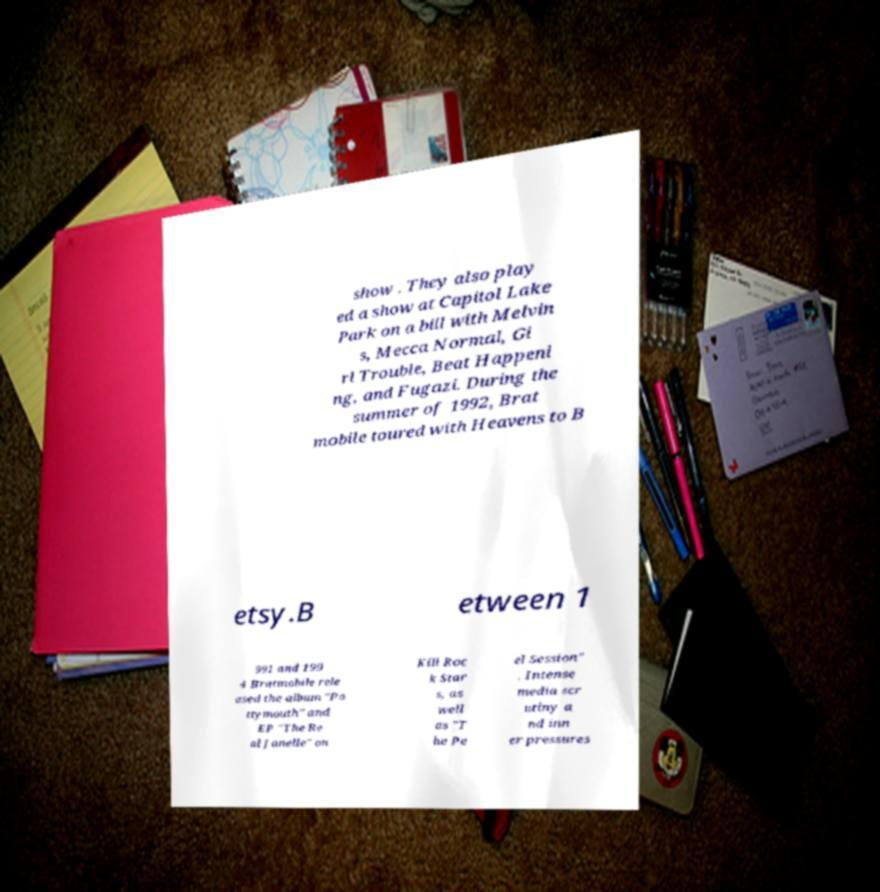What messages or text are displayed in this image? I need them in a readable, typed format. show . They also play ed a show at Capitol Lake Park on a bill with Melvin s, Mecca Normal, Gi rl Trouble, Beat Happeni ng, and Fugazi. During the summer of 1992, Brat mobile toured with Heavens to B etsy.B etween 1 991 and 199 4 Bratmobile rele ased the album "Po ttymouth" and EP "The Re al Janelle" on Kill Roc k Star s, as well as "T he Pe el Session" . Intense media scr utiny a nd inn er pressures 